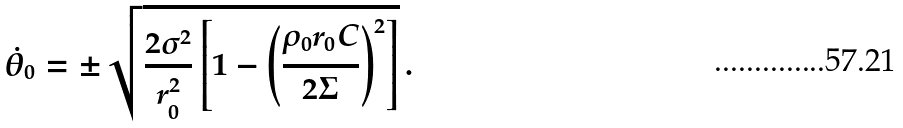Convert formula to latex. <formula><loc_0><loc_0><loc_500><loc_500>\dot { \theta } _ { 0 } = \pm \sqrt { \frac { 2 \sigma ^ { 2 } } { r _ { 0 } ^ { 2 } } \left [ 1 - \left ( \frac { \rho _ { 0 } r _ { 0 } C } { 2 \Sigma } \right ) ^ { 2 } \right ] } \, .</formula> 